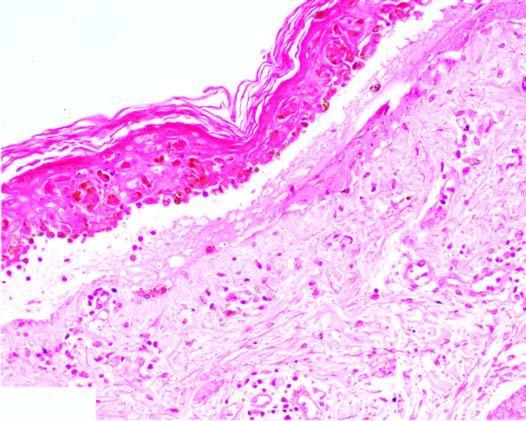s there pronounced dermoepidermal interface dermatitis?
Answer the question using a single word or phrase. Yes 